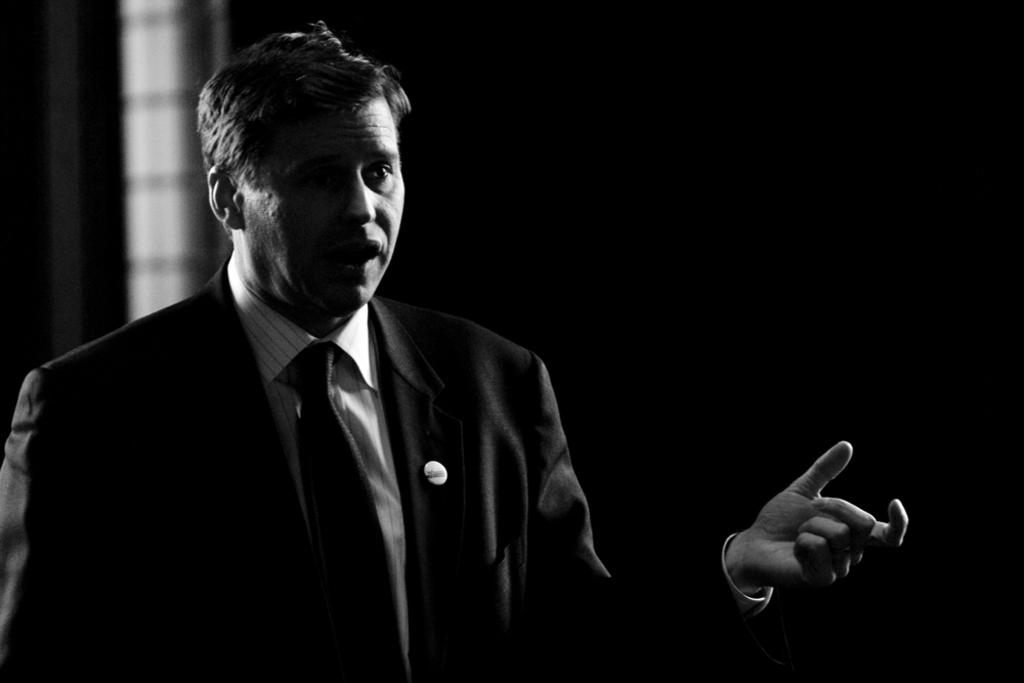What is the main subject of the image? There is a person standing in the image. What is the person doing in the image? The person appears to be talking. What can be seen in the background of the image? There is a window visible in the background of the image. What type of marble is visible on the floor in the image? There is no marble visible on the floor in the image. Is there a maid present in the image? There is no mention of a maid in the provided facts, so we cannot determine if one is present in the image. 